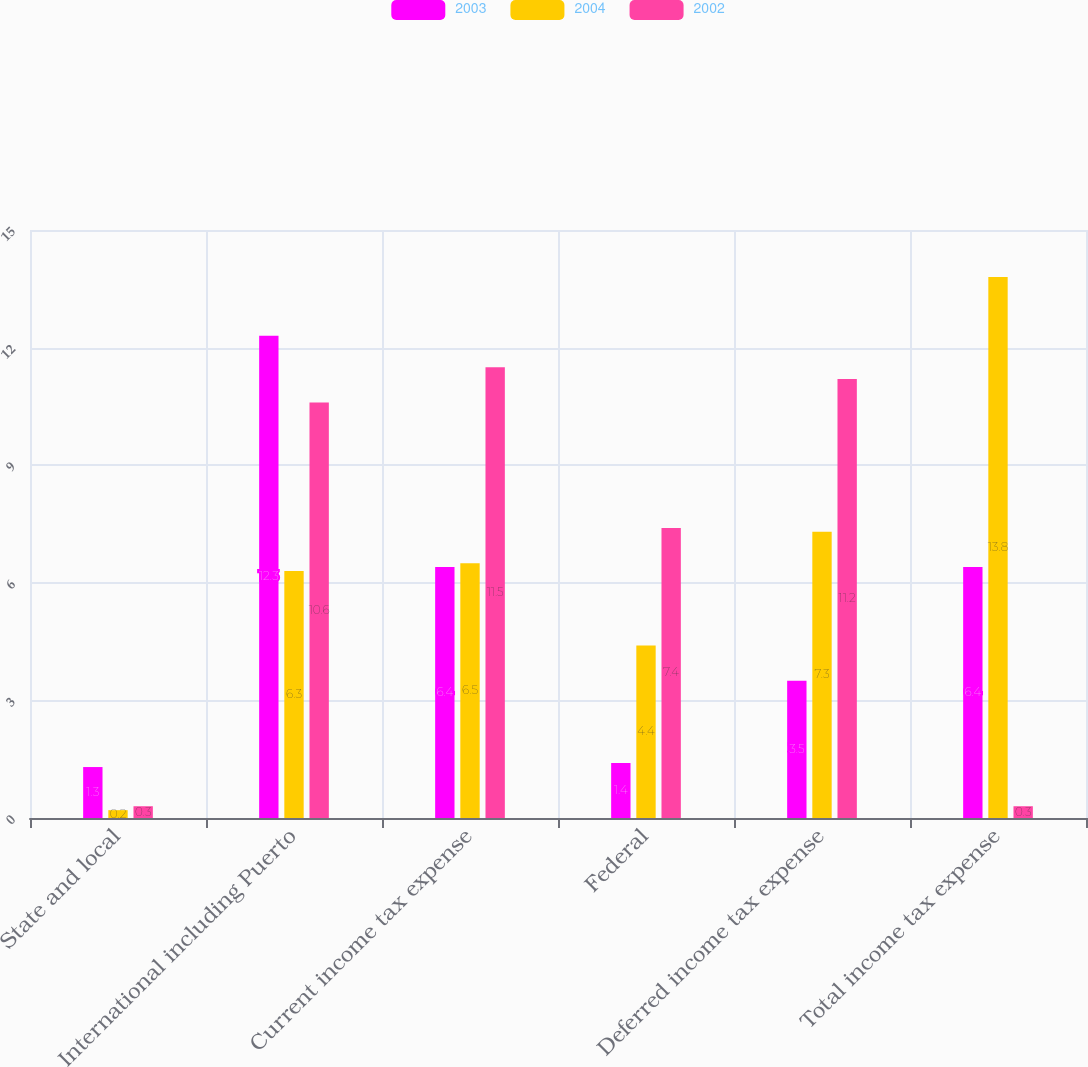<chart> <loc_0><loc_0><loc_500><loc_500><stacked_bar_chart><ecel><fcel>State and local<fcel>International including Puerto<fcel>Current income tax expense<fcel>Federal<fcel>Deferred income tax expense<fcel>Total income tax expense<nl><fcel>2003<fcel>1.3<fcel>12.3<fcel>6.4<fcel>1.4<fcel>3.5<fcel>6.4<nl><fcel>2004<fcel>0.2<fcel>6.3<fcel>6.5<fcel>4.4<fcel>7.3<fcel>13.8<nl><fcel>2002<fcel>0.3<fcel>10.6<fcel>11.5<fcel>7.4<fcel>11.2<fcel>0.3<nl></chart> 